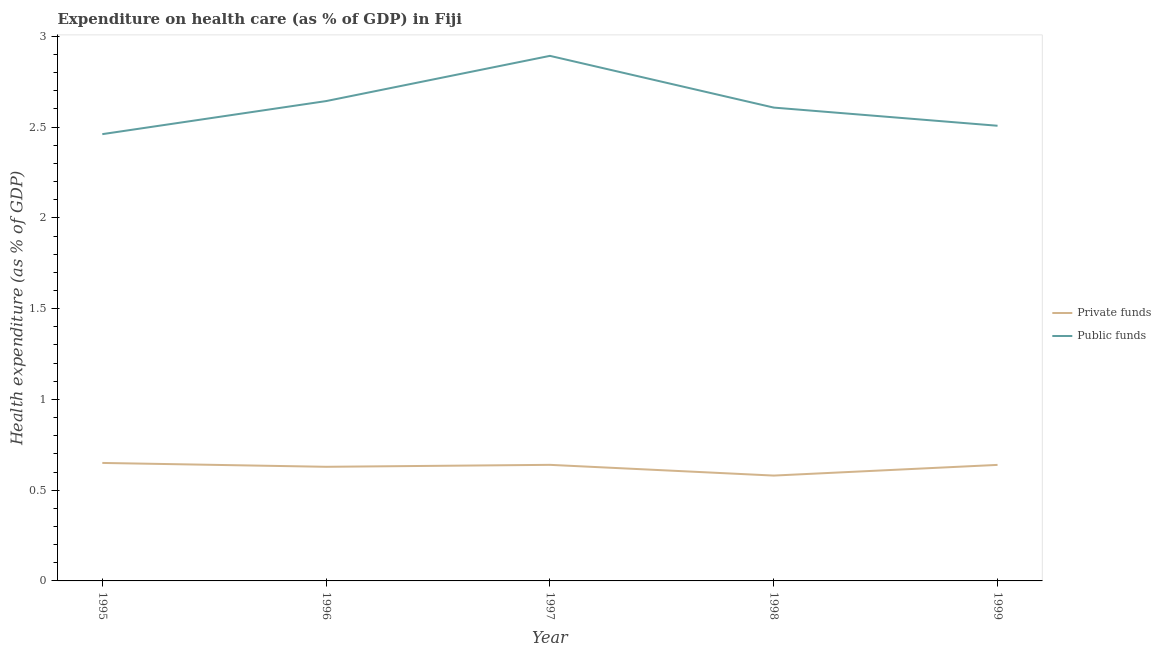Does the line corresponding to amount of private funds spent in healthcare intersect with the line corresponding to amount of public funds spent in healthcare?
Offer a terse response. No. What is the amount of private funds spent in healthcare in 1998?
Your response must be concise. 0.58. Across all years, what is the maximum amount of private funds spent in healthcare?
Offer a very short reply. 0.65. Across all years, what is the minimum amount of private funds spent in healthcare?
Keep it short and to the point. 0.58. In which year was the amount of private funds spent in healthcare maximum?
Make the answer very short. 1995. What is the total amount of public funds spent in healthcare in the graph?
Provide a succinct answer. 13.11. What is the difference between the amount of public funds spent in healthcare in 1996 and that in 1998?
Your response must be concise. 0.04. What is the difference between the amount of public funds spent in healthcare in 1997 and the amount of private funds spent in healthcare in 1996?
Give a very brief answer. 2.26. What is the average amount of public funds spent in healthcare per year?
Offer a very short reply. 2.62. In the year 1998, what is the difference between the amount of private funds spent in healthcare and amount of public funds spent in healthcare?
Your answer should be compact. -2.03. What is the ratio of the amount of public funds spent in healthcare in 1996 to that in 1999?
Keep it short and to the point. 1.05. Is the difference between the amount of private funds spent in healthcare in 1997 and 1999 greater than the difference between the amount of public funds spent in healthcare in 1997 and 1999?
Keep it short and to the point. No. What is the difference between the highest and the second highest amount of private funds spent in healthcare?
Ensure brevity in your answer.  0.01. What is the difference between the highest and the lowest amount of private funds spent in healthcare?
Your answer should be very brief. 0.07. In how many years, is the amount of public funds spent in healthcare greater than the average amount of public funds spent in healthcare taken over all years?
Your answer should be very brief. 2. Is the sum of the amount of private funds spent in healthcare in 1998 and 1999 greater than the maximum amount of public funds spent in healthcare across all years?
Offer a terse response. No. Does the amount of public funds spent in healthcare monotonically increase over the years?
Your answer should be very brief. No. Is the amount of private funds spent in healthcare strictly less than the amount of public funds spent in healthcare over the years?
Offer a very short reply. Yes. What is the difference between two consecutive major ticks on the Y-axis?
Make the answer very short. 0.5. Are the values on the major ticks of Y-axis written in scientific E-notation?
Your answer should be compact. No. Does the graph contain grids?
Your answer should be compact. No. How many legend labels are there?
Provide a succinct answer. 2. How are the legend labels stacked?
Offer a terse response. Vertical. What is the title of the graph?
Provide a short and direct response. Expenditure on health care (as % of GDP) in Fiji. What is the label or title of the Y-axis?
Provide a short and direct response. Health expenditure (as % of GDP). What is the Health expenditure (as % of GDP) of Private funds in 1995?
Your response must be concise. 0.65. What is the Health expenditure (as % of GDP) of Public funds in 1995?
Offer a terse response. 2.46. What is the Health expenditure (as % of GDP) of Private funds in 1996?
Provide a short and direct response. 0.63. What is the Health expenditure (as % of GDP) in Public funds in 1996?
Your response must be concise. 2.64. What is the Health expenditure (as % of GDP) in Private funds in 1997?
Your answer should be compact. 0.64. What is the Health expenditure (as % of GDP) of Public funds in 1997?
Provide a succinct answer. 2.89. What is the Health expenditure (as % of GDP) in Private funds in 1998?
Your answer should be very brief. 0.58. What is the Health expenditure (as % of GDP) in Public funds in 1998?
Offer a terse response. 2.61. What is the Health expenditure (as % of GDP) of Private funds in 1999?
Your answer should be compact. 0.64. What is the Health expenditure (as % of GDP) of Public funds in 1999?
Keep it short and to the point. 2.51. Across all years, what is the maximum Health expenditure (as % of GDP) of Private funds?
Make the answer very short. 0.65. Across all years, what is the maximum Health expenditure (as % of GDP) in Public funds?
Your answer should be compact. 2.89. Across all years, what is the minimum Health expenditure (as % of GDP) of Private funds?
Offer a very short reply. 0.58. Across all years, what is the minimum Health expenditure (as % of GDP) of Public funds?
Provide a short and direct response. 2.46. What is the total Health expenditure (as % of GDP) in Private funds in the graph?
Your answer should be compact. 3.14. What is the total Health expenditure (as % of GDP) in Public funds in the graph?
Offer a terse response. 13.11. What is the difference between the Health expenditure (as % of GDP) of Private funds in 1995 and that in 1996?
Make the answer very short. 0.02. What is the difference between the Health expenditure (as % of GDP) of Public funds in 1995 and that in 1996?
Ensure brevity in your answer.  -0.18. What is the difference between the Health expenditure (as % of GDP) of Private funds in 1995 and that in 1997?
Provide a short and direct response. 0.01. What is the difference between the Health expenditure (as % of GDP) in Public funds in 1995 and that in 1997?
Keep it short and to the point. -0.43. What is the difference between the Health expenditure (as % of GDP) of Private funds in 1995 and that in 1998?
Keep it short and to the point. 0.07. What is the difference between the Health expenditure (as % of GDP) in Public funds in 1995 and that in 1998?
Your answer should be very brief. -0.15. What is the difference between the Health expenditure (as % of GDP) in Private funds in 1995 and that in 1999?
Keep it short and to the point. 0.01. What is the difference between the Health expenditure (as % of GDP) of Public funds in 1995 and that in 1999?
Your answer should be very brief. -0.05. What is the difference between the Health expenditure (as % of GDP) in Private funds in 1996 and that in 1997?
Give a very brief answer. -0.01. What is the difference between the Health expenditure (as % of GDP) in Public funds in 1996 and that in 1997?
Your answer should be compact. -0.25. What is the difference between the Health expenditure (as % of GDP) of Private funds in 1996 and that in 1998?
Your response must be concise. 0.05. What is the difference between the Health expenditure (as % of GDP) in Public funds in 1996 and that in 1998?
Provide a short and direct response. 0.04. What is the difference between the Health expenditure (as % of GDP) in Private funds in 1996 and that in 1999?
Your answer should be compact. -0.01. What is the difference between the Health expenditure (as % of GDP) of Public funds in 1996 and that in 1999?
Your answer should be compact. 0.14. What is the difference between the Health expenditure (as % of GDP) in Private funds in 1997 and that in 1998?
Give a very brief answer. 0.06. What is the difference between the Health expenditure (as % of GDP) in Public funds in 1997 and that in 1998?
Give a very brief answer. 0.28. What is the difference between the Health expenditure (as % of GDP) in Private funds in 1997 and that in 1999?
Your answer should be very brief. 0. What is the difference between the Health expenditure (as % of GDP) in Public funds in 1997 and that in 1999?
Ensure brevity in your answer.  0.39. What is the difference between the Health expenditure (as % of GDP) in Private funds in 1998 and that in 1999?
Ensure brevity in your answer.  -0.06. What is the difference between the Health expenditure (as % of GDP) of Public funds in 1998 and that in 1999?
Offer a very short reply. 0.1. What is the difference between the Health expenditure (as % of GDP) of Private funds in 1995 and the Health expenditure (as % of GDP) of Public funds in 1996?
Your response must be concise. -1.99. What is the difference between the Health expenditure (as % of GDP) of Private funds in 1995 and the Health expenditure (as % of GDP) of Public funds in 1997?
Provide a short and direct response. -2.24. What is the difference between the Health expenditure (as % of GDP) of Private funds in 1995 and the Health expenditure (as % of GDP) of Public funds in 1998?
Your response must be concise. -1.96. What is the difference between the Health expenditure (as % of GDP) in Private funds in 1995 and the Health expenditure (as % of GDP) in Public funds in 1999?
Your answer should be compact. -1.86. What is the difference between the Health expenditure (as % of GDP) of Private funds in 1996 and the Health expenditure (as % of GDP) of Public funds in 1997?
Your response must be concise. -2.26. What is the difference between the Health expenditure (as % of GDP) of Private funds in 1996 and the Health expenditure (as % of GDP) of Public funds in 1998?
Offer a very short reply. -1.98. What is the difference between the Health expenditure (as % of GDP) in Private funds in 1996 and the Health expenditure (as % of GDP) in Public funds in 1999?
Provide a succinct answer. -1.88. What is the difference between the Health expenditure (as % of GDP) of Private funds in 1997 and the Health expenditure (as % of GDP) of Public funds in 1998?
Provide a succinct answer. -1.97. What is the difference between the Health expenditure (as % of GDP) in Private funds in 1997 and the Health expenditure (as % of GDP) in Public funds in 1999?
Provide a short and direct response. -1.87. What is the difference between the Health expenditure (as % of GDP) in Private funds in 1998 and the Health expenditure (as % of GDP) in Public funds in 1999?
Make the answer very short. -1.93. What is the average Health expenditure (as % of GDP) of Private funds per year?
Offer a very short reply. 0.63. What is the average Health expenditure (as % of GDP) in Public funds per year?
Provide a succinct answer. 2.62. In the year 1995, what is the difference between the Health expenditure (as % of GDP) of Private funds and Health expenditure (as % of GDP) of Public funds?
Your answer should be compact. -1.81. In the year 1996, what is the difference between the Health expenditure (as % of GDP) of Private funds and Health expenditure (as % of GDP) of Public funds?
Give a very brief answer. -2.01. In the year 1997, what is the difference between the Health expenditure (as % of GDP) in Private funds and Health expenditure (as % of GDP) in Public funds?
Provide a short and direct response. -2.25. In the year 1998, what is the difference between the Health expenditure (as % of GDP) of Private funds and Health expenditure (as % of GDP) of Public funds?
Give a very brief answer. -2.03. In the year 1999, what is the difference between the Health expenditure (as % of GDP) in Private funds and Health expenditure (as % of GDP) in Public funds?
Provide a succinct answer. -1.87. What is the ratio of the Health expenditure (as % of GDP) in Private funds in 1995 to that in 1996?
Provide a succinct answer. 1.03. What is the ratio of the Health expenditure (as % of GDP) of Public funds in 1995 to that in 1996?
Give a very brief answer. 0.93. What is the ratio of the Health expenditure (as % of GDP) of Private funds in 1995 to that in 1997?
Make the answer very short. 1.02. What is the ratio of the Health expenditure (as % of GDP) of Public funds in 1995 to that in 1997?
Give a very brief answer. 0.85. What is the ratio of the Health expenditure (as % of GDP) of Private funds in 1995 to that in 1998?
Your answer should be very brief. 1.12. What is the ratio of the Health expenditure (as % of GDP) in Public funds in 1995 to that in 1998?
Provide a short and direct response. 0.94. What is the ratio of the Health expenditure (as % of GDP) of Private funds in 1995 to that in 1999?
Give a very brief answer. 1.02. What is the ratio of the Health expenditure (as % of GDP) of Public funds in 1995 to that in 1999?
Your response must be concise. 0.98. What is the ratio of the Health expenditure (as % of GDP) in Private funds in 1996 to that in 1997?
Provide a short and direct response. 0.98. What is the ratio of the Health expenditure (as % of GDP) of Public funds in 1996 to that in 1997?
Keep it short and to the point. 0.91. What is the ratio of the Health expenditure (as % of GDP) in Private funds in 1996 to that in 1998?
Your answer should be compact. 1.08. What is the ratio of the Health expenditure (as % of GDP) of Public funds in 1996 to that in 1998?
Ensure brevity in your answer.  1.01. What is the ratio of the Health expenditure (as % of GDP) in Private funds in 1996 to that in 1999?
Offer a very short reply. 0.98. What is the ratio of the Health expenditure (as % of GDP) in Public funds in 1996 to that in 1999?
Your answer should be compact. 1.05. What is the ratio of the Health expenditure (as % of GDP) of Private funds in 1997 to that in 1998?
Keep it short and to the point. 1.1. What is the ratio of the Health expenditure (as % of GDP) of Public funds in 1997 to that in 1998?
Your answer should be very brief. 1.11. What is the ratio of the Health expenditure (as % of GDP) of Public funds in 1997 to that in 1999?
Provide a succinct answer. 1.15. What is the ratio of the Health expenditure (as % of GDP) of Private funds in 1998 to that in 1999?
Your answer should be very brief. 0.91. What is the ratio of the Health expenditure (as % of GDP) of Public funds in 1998 to that in 1999?
Give a very brief answer. 1.04. What is the difference between the highest and the second highest Health expenditure (as % of GDP) of Private funds?
Provide a short and direct response. 0.01. What is the difference between the highest and the second highest Health expenditure (as % of GDP) in Public funds?
Your response must be concise. 0.25. What is the difference between the highest and the lowest Health expenditure (as % of GDP) of Private funds?
Make the answer very short. 0.07. What is the difference between the highest and the lowest Health expenditure (as % of GDP) of Public funds?
Keep it short and to the point. 0.43. 